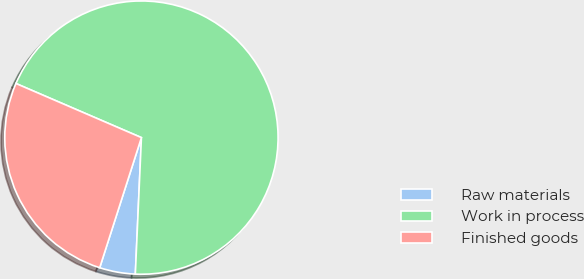Convert chart to OTSL. <chart><loc_0><loc_0><loc_500><loc_500><pie_chart><fcel>Raw materials<fcel>Work in process<fcel>Finished goods<nl><fcel>4.23%<fcel>69.23%<fcel>26.54%<nl></chart> 